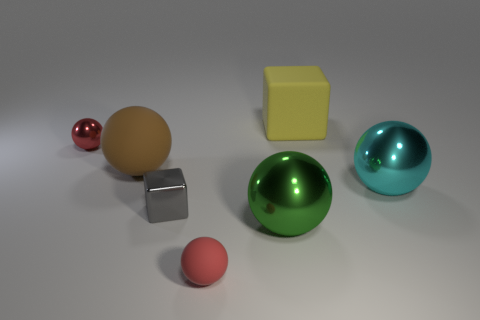There is a large sphere that is in front of the tiny block; is it the same color as the tiny rubber object?
Give a very brief answer. No. Is there a cyan object that has the same material as the big green thing?
Your answer should be compact. Yes. Are there fewer green shiny objects on the left side of the small gray shiny block than small red objects?
Give a very brief answer. Yes. Is the size of the shiny ball behind the cyan sphere the same as the gray object?
Provide a short and direct response. Yes. What number of other shiny objects have the same shape as the large green metallic thing?
Ensure brevity in your answer.  2. What is the size of the red object that is made of the same material as the big green thing?
Your answer should be very brief. Small. Are there an equal number of brown things to the left of the tiny gray thing and large cyan rubber cubes?
Offer a very short reply. No. Is the color of the big matte cube the same as the small rubber ball?
Provide a short and direct response. No. Is the shape of the matte object that is to the left of the gray metallic object the same as the tiny red object to the left of the gray block?
Your response must be concise. Yes. What is the material of the green thing that is the same shape as the big cyan object?
Your answer should be compact. Metal. 